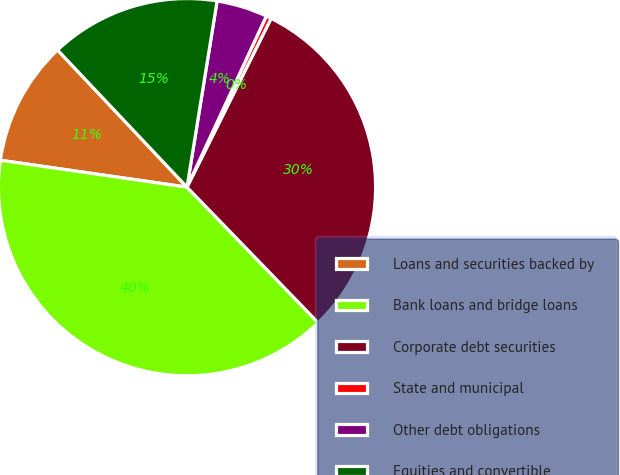<chart> <loc_0><loc_0><loc_500><loc_500><pie_chart><fcel>Loans and securities backed by<fcel>Bank loans and bridge loans<fcel>Corporate debt securities<fcel>State and municipal<fcel>Other debt obligations<fcel>Equities and convertible<nl><fcel>10.68%<fcel>39.52%<fcel>30.4%<fcel>0.45%<fcel>4.36%<fcel>14.59%<nl></chart> 